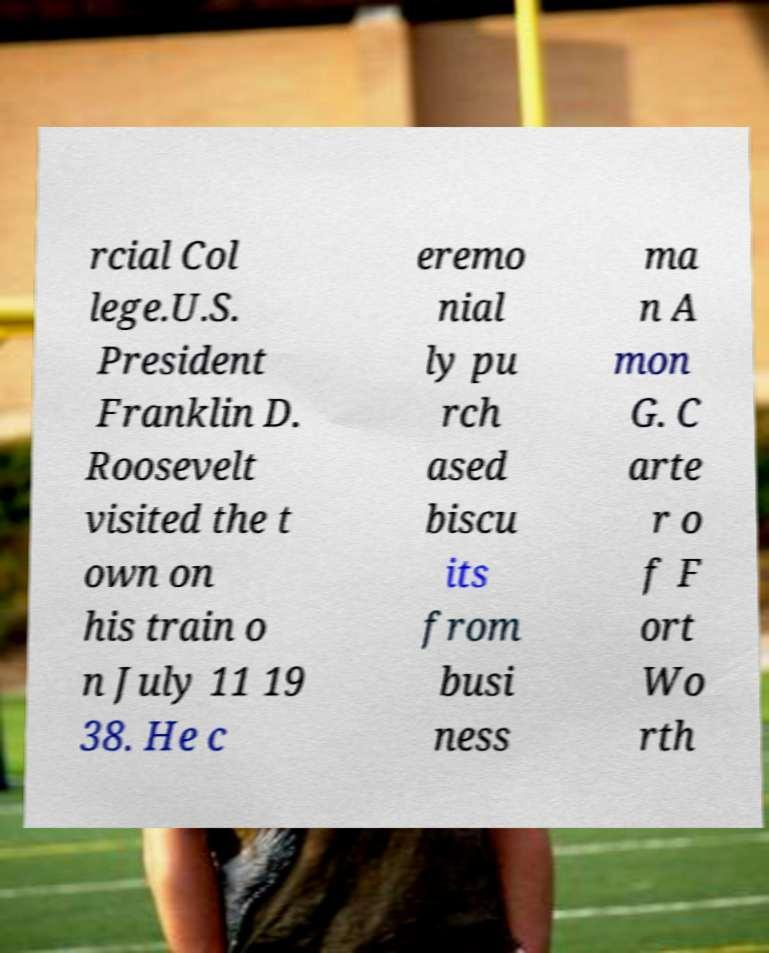Please read and relay the text visible in this image. What does it say? rcial Col lege.U.S. President Franklin D. Roosevelt visited the t own on his train o n July 11 19 38. He c eremo nial ly pu rch ased biscu its from busi ness ma n A mon G. C arte r o f F ort Wo rth 